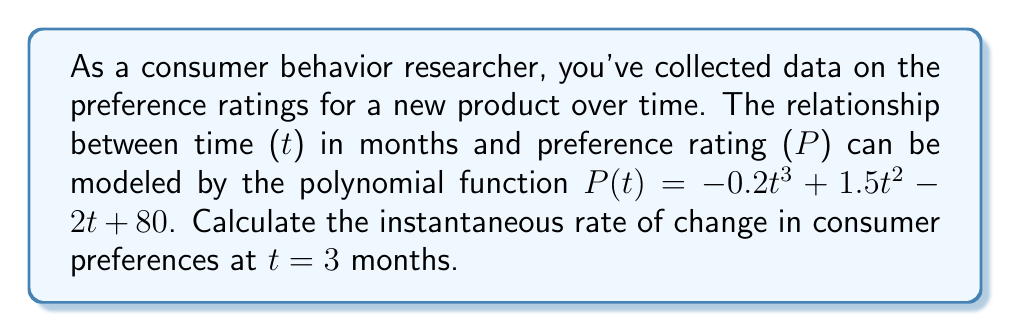Give your solution to this math problem. To find the instantaneous rate of change at a specific point, we need to calculate the derivative of the polynomial function and evaluate it at the given point.

Step 1: Find the derivative of $P(t)$.
$$\frac{d}{dt}P(t) = \frac{d}{dt}(-0.2t^3 + 1.5t^2 - 2t + 80)$$
$$P'(t) = -0.6t^2 + 3t - 2$$

Step 2: Evaluate the derivative at t = 3.
$$P'(3) = -0.6(3)^2 + 3(3) - 2$$
$$P'(3) = -0.6(9) + 9 - 2$$
$$P'(3) = -5.4 + 9 - 2$$
$$P'(3) = 1.6$$

The instantaneous rate of change at t = 3 months is 1.6 units per month.
Answer: 1.6 units/month 